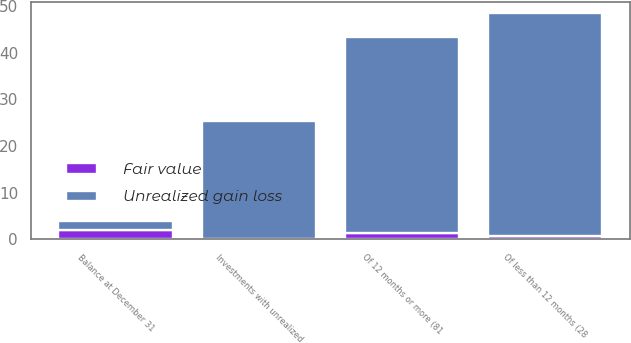<chart> <loc_0><loc_0><loc_500><loc_500><stacked_bar_chart><ecel><fcel>Of less than 12 months (28<fcel>Of 12 months or more (81<fcel>Investments with unrealized<fcel>Balance at December 31<nl><fcel>Unrealized gain loss<fcel>47.7<fcel>41.9<fcel>25.2<fcel>2<nl><fcel>Fair value<fcel>0.7<fcel>1.4<fcel>0.1<fcel>2<nl></chart> 